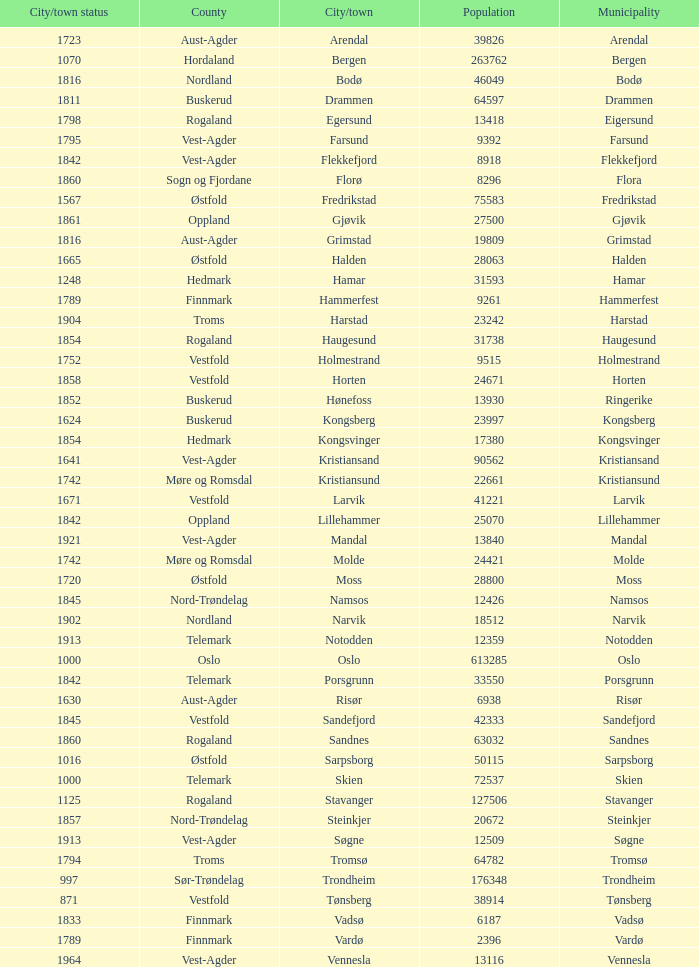What are the cities/towns located in the municipality of Moss? Moss. 